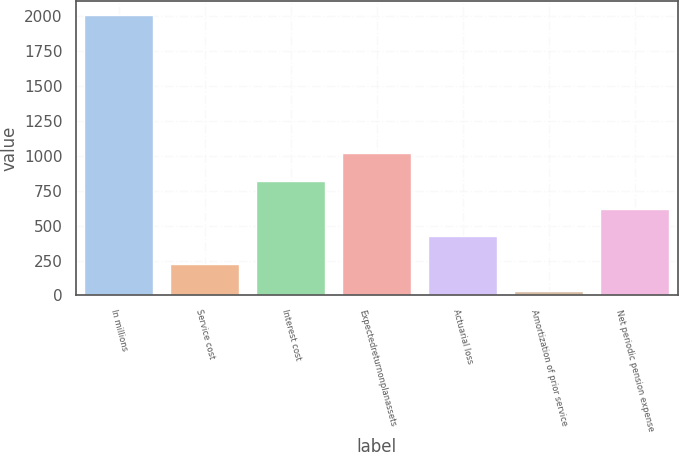Convert chart to OTSL. <chart><loc_0><loc_0><loc_500><loc_500><bar_chart><fcel>In millions<fcel>Service cost<fcel>Interest cost<fcel>Expectedreturnonplanassets<fcel>Actuarial loss<fcel>Amortization of prior service<fcel>Net periodic pension expense<nl><fcel>2008<fcel>226.9<fcel>820.6<fcel>1018.5<fcel>424.8<fcel>29<fcel>622.7<nl></chart> 